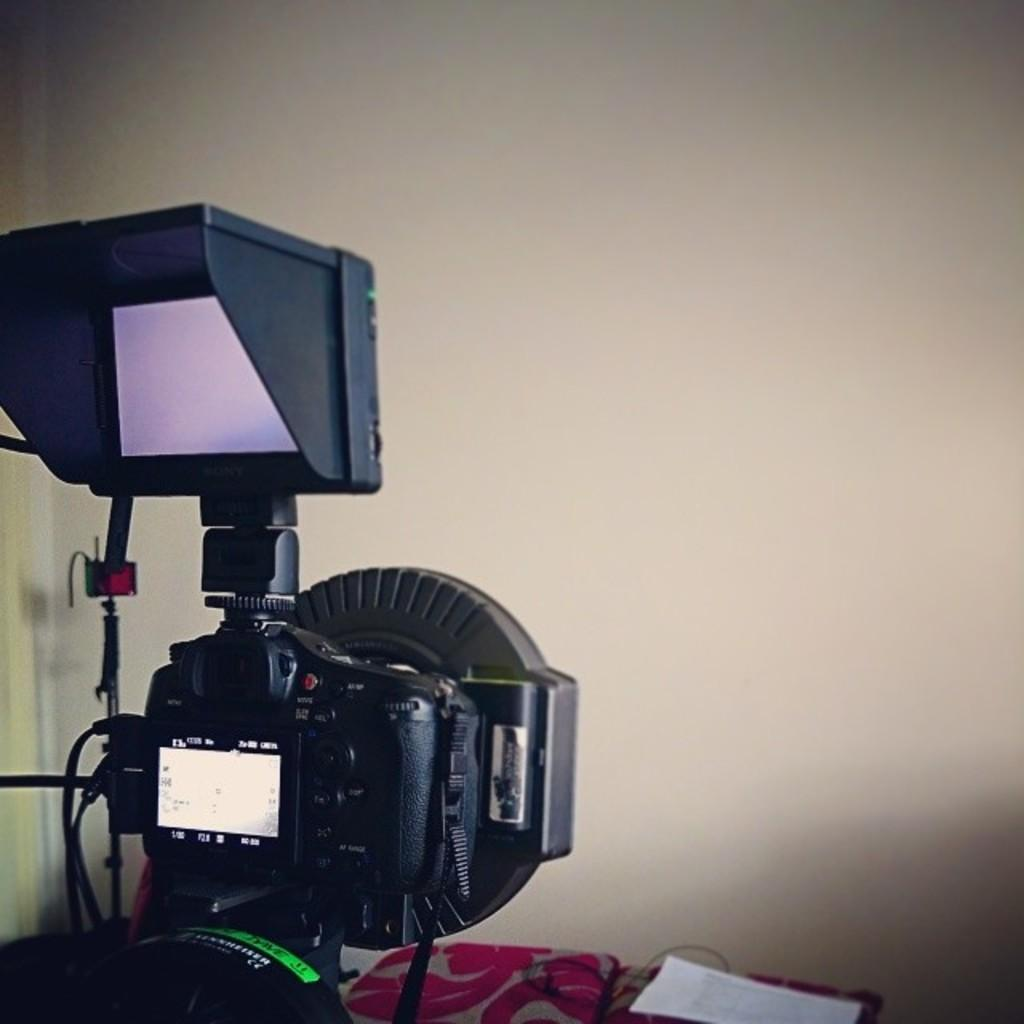What device is present in the image? There is a video camera in the image. What is on the table in the image? There is a paper on the table in the image. What can be seen in the background of the image? There is a wall visible in the image. How many insects are crawling on the video camera in the image? There are no insects present in the image; it only shows a video camera, a paper on the table, and a wall in the background. 